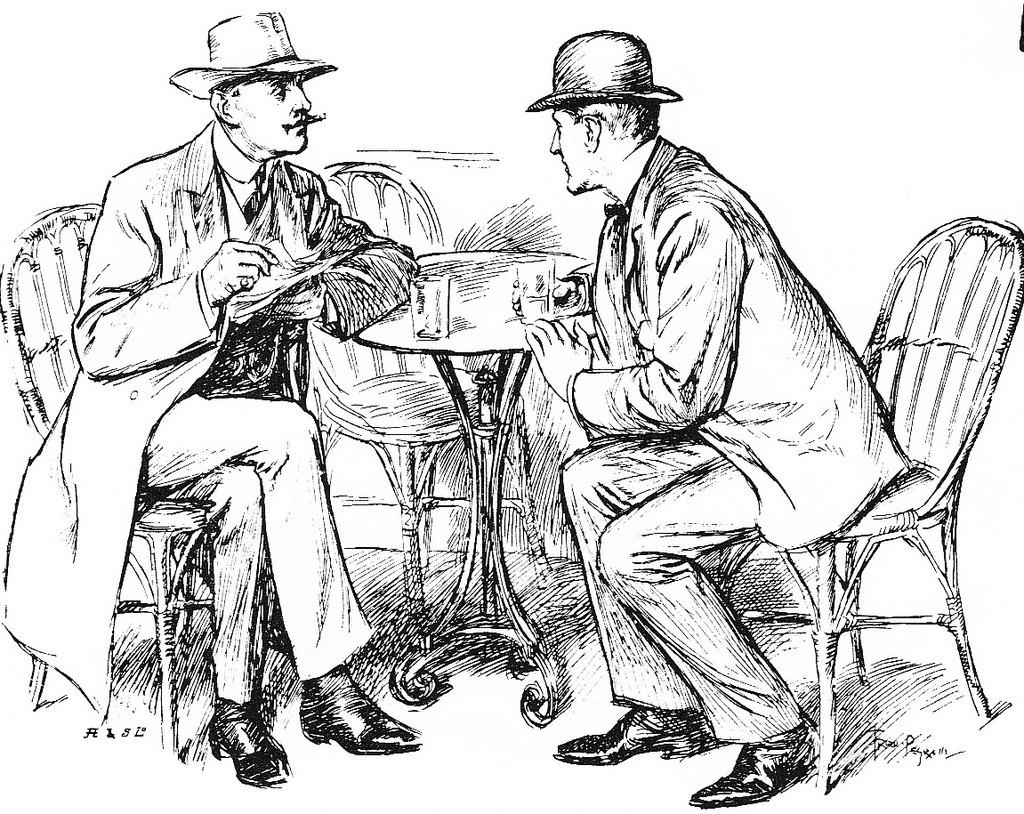What type of drawing is depicted in the image? The image is a pencil sketch. How many people are in the sketch? There are two men in the sketch. What are the men doing in the sketch? The men are sitting beside a table. What are the men wearing in the sketch? Both men are wearing jackets and hats. What objects are on the table in the sketch? There are two glasses on the table. What type of rhythm can be heard in the sketch? There is no sound or rhythm present in the pencil sketch, as it is a static image. 